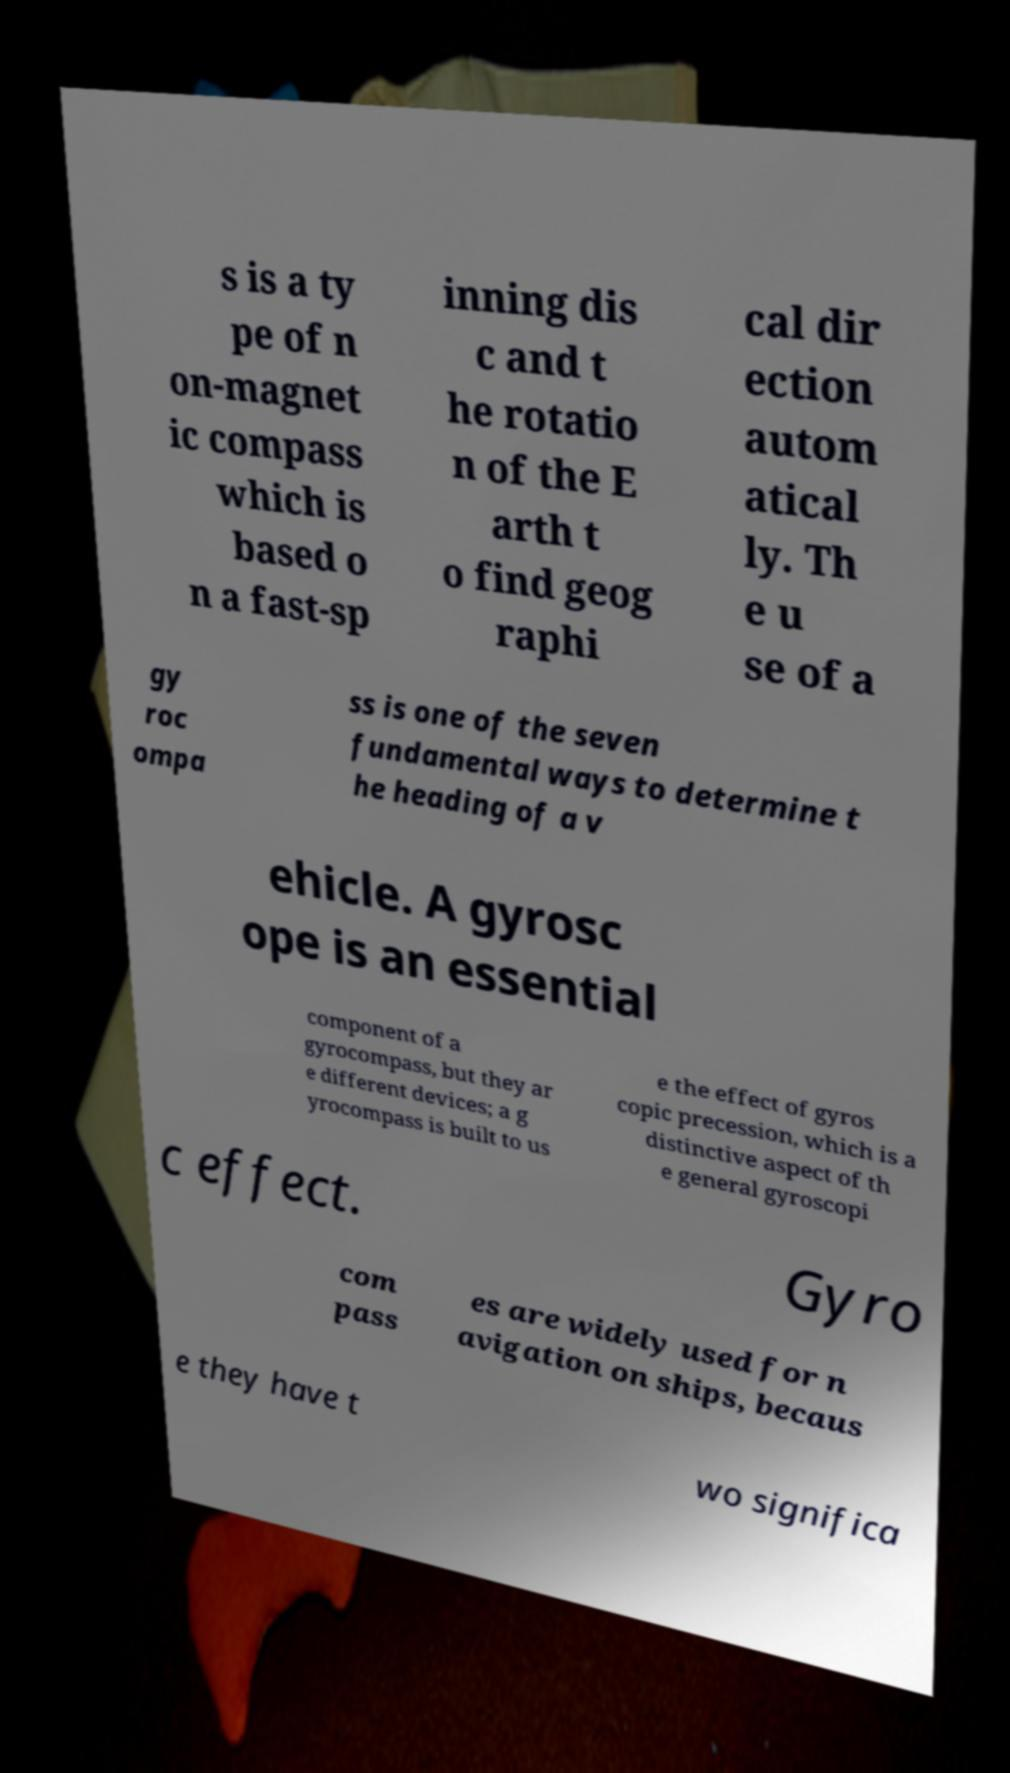There's text embedded in this image that I need extracted. Can you transcribe it verbatim? s is a ty pe of n on-magnet ic compass which is based o n a fast-sp inning dis c and t he rotatio n of the E arth t o find geog raphi cal dir ection autom atical ly. Th e u se of a gy roc ompa ss is one of the seven fundamental ways to determine t he heading of a v ehicle. A gyrosc ope is an essential component of a gyrocompass, but they ar e different devices; a g yrocompass is built to us e the effect of gyros copic precession, which is a distinctive aspect of th e general gyroscopi c effect. Gyro com pass es are widely used for n avigation on ships, becaus e they have t wo significa 